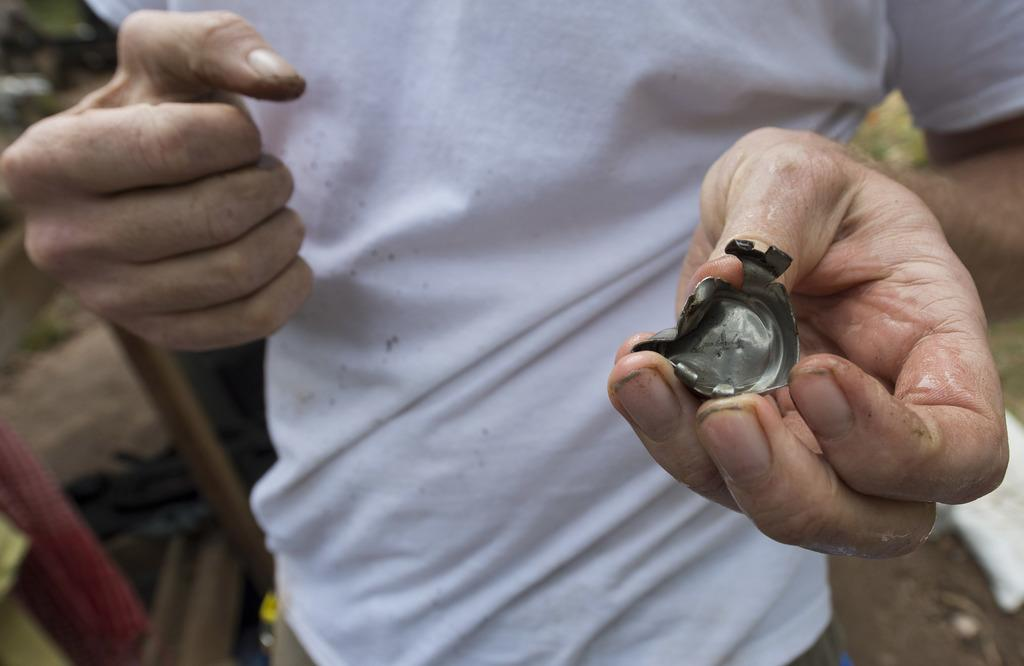What can be seen in the image? There is a person in the image. What is the person holding in their hand? The person is holding an object in their hand. Can you describe the person's clothing? The person is wearing a white T-shirt. How would you describe the background of the image? The background of the image is blurred. Is there a dog in the image? No, there is no dog present in the image. Can you tell me where the toothpaste is located in the image? There is no toothpaste present in the image. 